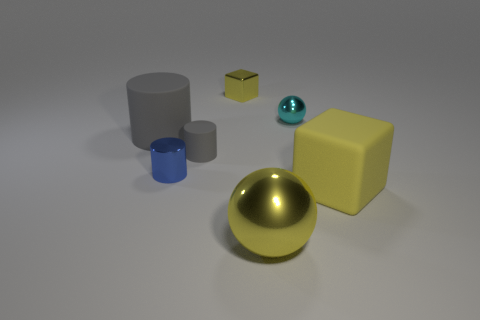Add 2 tiny shiny things. How many objects exist? 9 Subtract all blocks. How many objects are left? 5 Add 2 cylinders. How many cylinders exist? 5 Subtract 0 gray cubes. How many objects are left? 7 Subtract all cyan metallic balls. Subtract all small matte things. How many objects are left? 5 Add 5 small cyan metallic objects. How many small cyan metallic objects are left? 6 